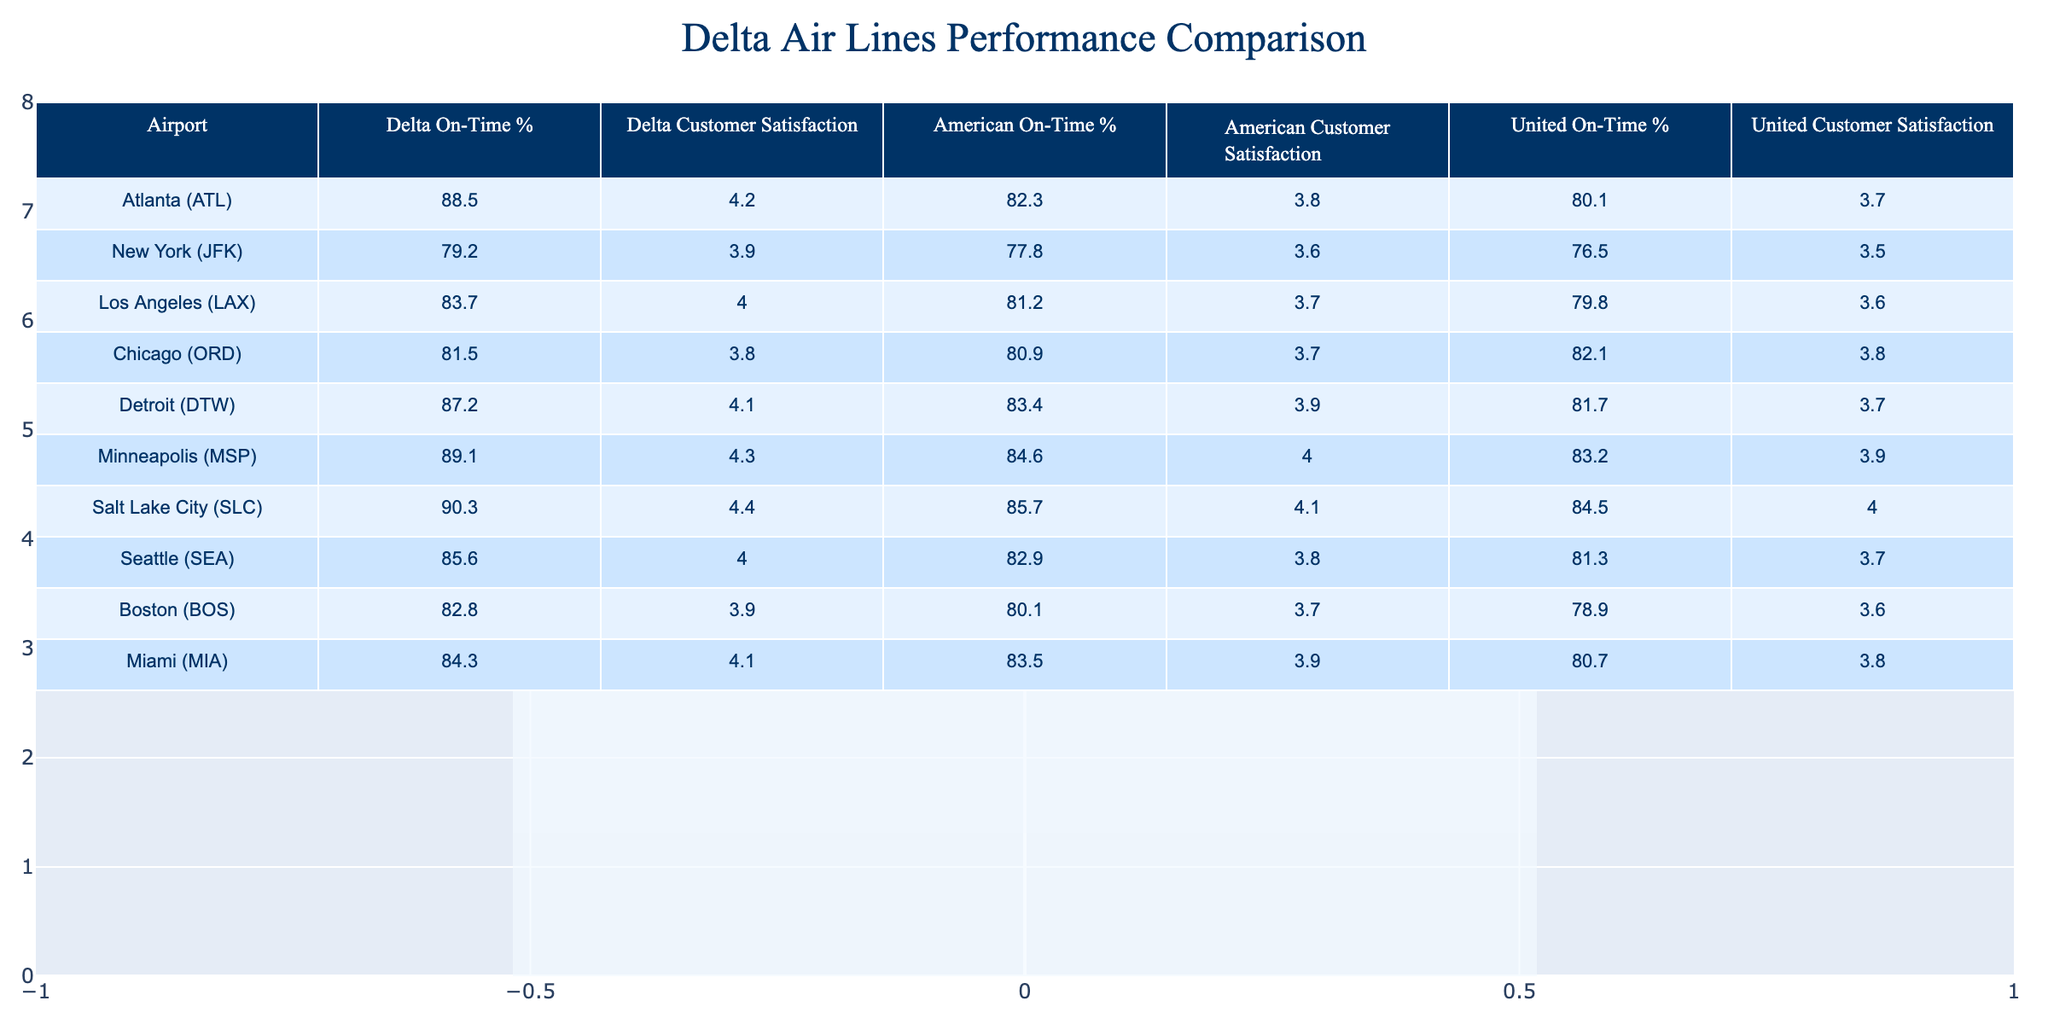What is Delta's on-time performance percentage at Atlanta airport? Looking at the table, the value listed under "Delta On-Time %" for Atlanta (ATL) is 88.5%.
Answer: 88.5% Which airport has the highest customer satisfaction rating for Delta? By reviewing the "Delta Customer Satisfaction" column, we see that Minneapolis (MSP) has the highest rating at 4.3.
Answer: 4.3 What is the difference in on-time performance percentage between Delta and American Airlines at Los Angeles? Delta's on-time performance at Los Angeles (LAX) is 83.7% and American's is 81.2%. The difference is calculated as 83.7 - 81.2 = 2.5%.
Answer: 2.5% Is Delta's on-time performance higher than United's at New York? Delta's on-time performance at JFK is 79.2%, while United's is 76.5%. Since 79.2 is greater than 76.5, the answer is yes.
Answer: Yes What is the average customer satisfaction rating for American Airlines across all airports listed? To find the average, we sum American's customer satisfaction ratings (3.8, 3.6, 3.7, 3.7, 3.9, 4.0, 4.1, 3.6, 3.8) resulting in 33.2, and divide by 9 airports leading to an average of 33.2 / 9 ≈ 3.69.
Answer: 3.69 Which two airports have the lowest customer satisfaction ratings for Delta? By examining the "Delta Customer Satisfaction" column, we find that Chicago (ORD) has 3.8 and New York (JFK) has 3.9, making them the two lowest ratings listed for Delta.
Answer: Chicago (ORD), New York (JFK) What percentage of customer satisfaction ratings for Delta is above 4.0? The ratings above 4.0 are from Minneapolis (4.3), Salt Lake City (4.4), and Atlanta (4.2). That makes 3 out of 9 total airports, which gives us (3/9) * 100 = 33.3%.
Answer: 33.3% Which airline has the best on-time performance in Salt Lake City? In Salt Lake City, Delta has 90.3%, American has 85.7%, and United has 84.5%. Delta's 90.3% is the highest of the three.
Answer: Delta What is the combined customer satisfaction rating for Delta and American Airlines at Miami? Delta's satisfaction is 4.1 and American's is 3.9 at Miami. Adding them gives 4.1 + 3.9 = 8.0.
Answer: 8.0 Does Detroit have a higher Delta customer satisfaction rating compared to Chicago? Detroit has a rating of 4.1 for Delta, and Chicago has 3.8, meaning Detroit's rating is higher.
Answer: Yes 